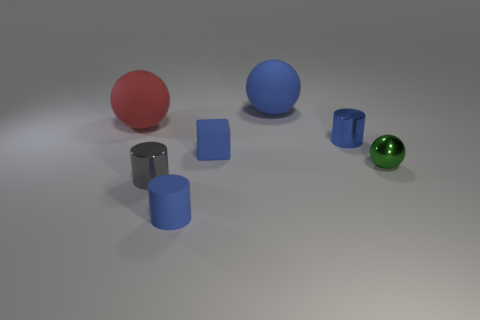There is another tiny cylinder that is the same color as the matte cylinder; what is it made of?
Make the answer very short. Metal. The other blue object that is the same shape as the blue metallic object is what size?
Your answer should be compact. Small. Are there any tiny things that are to the left of the metallic cylinder that is behind the green shiny ball?
Give a very brief answer. Yes. Does the rubber block have the same color as the small matte cylinder?
Your response must be concise. Yes. Are there more large objects to the left of the gray cylinder than blue matte cylinders that are behind the matte cube?
Offer a very short reply. Yes. Is the size of the blue thing left of the tiny blue matte cube the same as the matte sphere that is on the right side of the tiny block?
Your answer should be compact. No. The matte cube that is the same color as the small rubber cylinder is what size?
Offer a terse response. Small. What color is the large ball that is made of the same material as the big red thing?
Offer a very short reply. Blue. Are the green thing and the tiny blue cylinder on the left side of the large blue sphere made of the same material?
Your answer should be very brief. No. There is a blue sphere that is the same material as the small blue block; what size is it?
Your answer should be very brief. Large. 